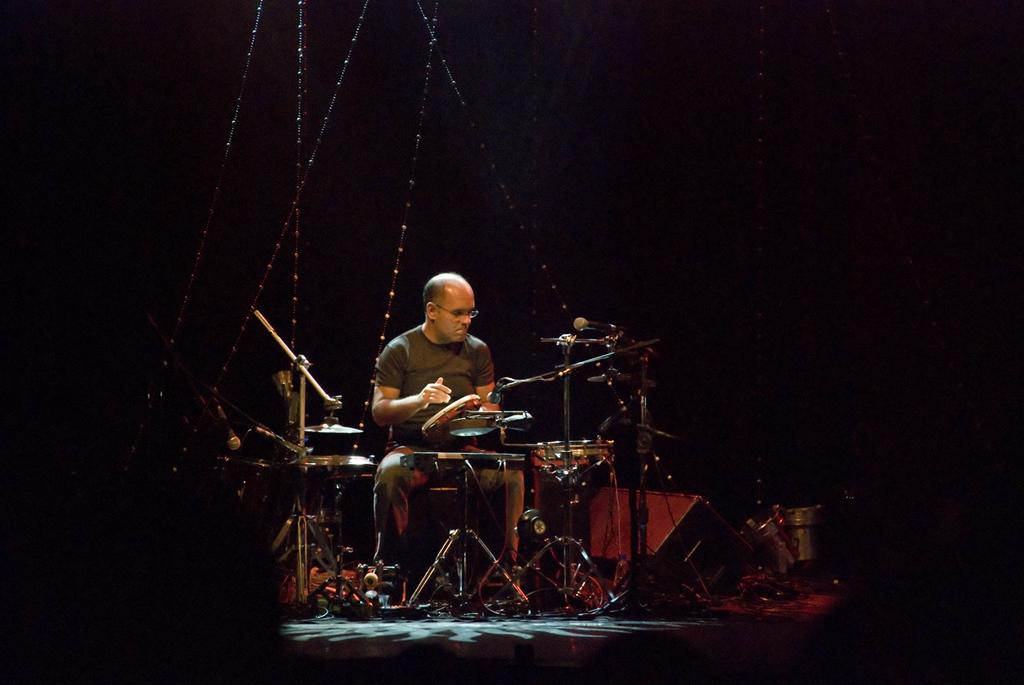What is the main subject of the image? There is a man playing drums in the image. What can be seen in the front of the image? There is a band setup in the front of the image. How would you describe the lighting in the image? The background of the image is dark. How does the horse contribute to the band's performance in the image? There is no horse present in the image, so it cannot contribute to the band's performance. 